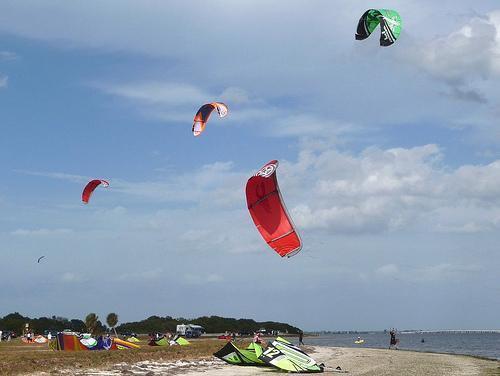The inflatable wing used to fly in which game?
Indicate the correct choice and explain in the format: 'Answer: answer
Rationale: rationale.'
Options: Skating, paragliding, kiting, parachuting. Answer: paragliding.
Rationale: The wing is for paragliding. 